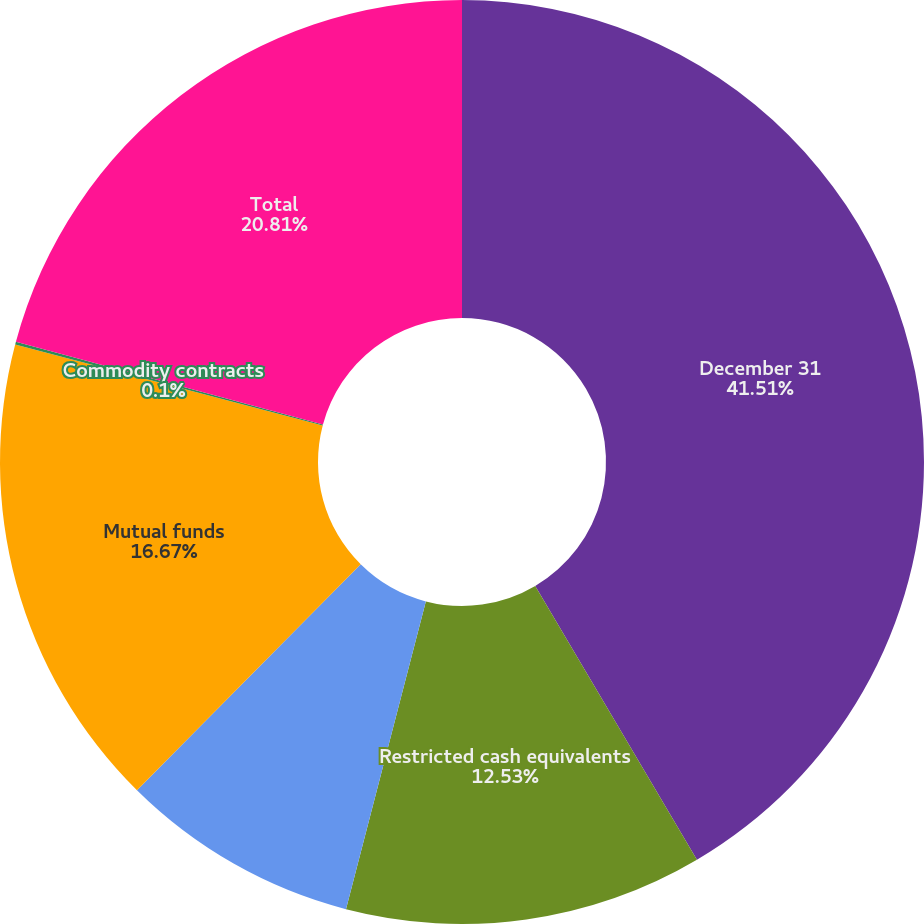Convert chart to OTSL. <chart><loc_0><loc_0><loc_500><loc_500><pie_chart><fcel>December 31<fcel>Restricted cash equivalents<fcel>Nonqualified deferred<fcel>Mutual funds<fcel>Commodity contracts<fcel>Total<nl><fcel>41.51%<fcel>12.53%<fcel>8.38%<fcel>16.67%<fcel>0.1%<fcel>20.81%<nl></chart> 